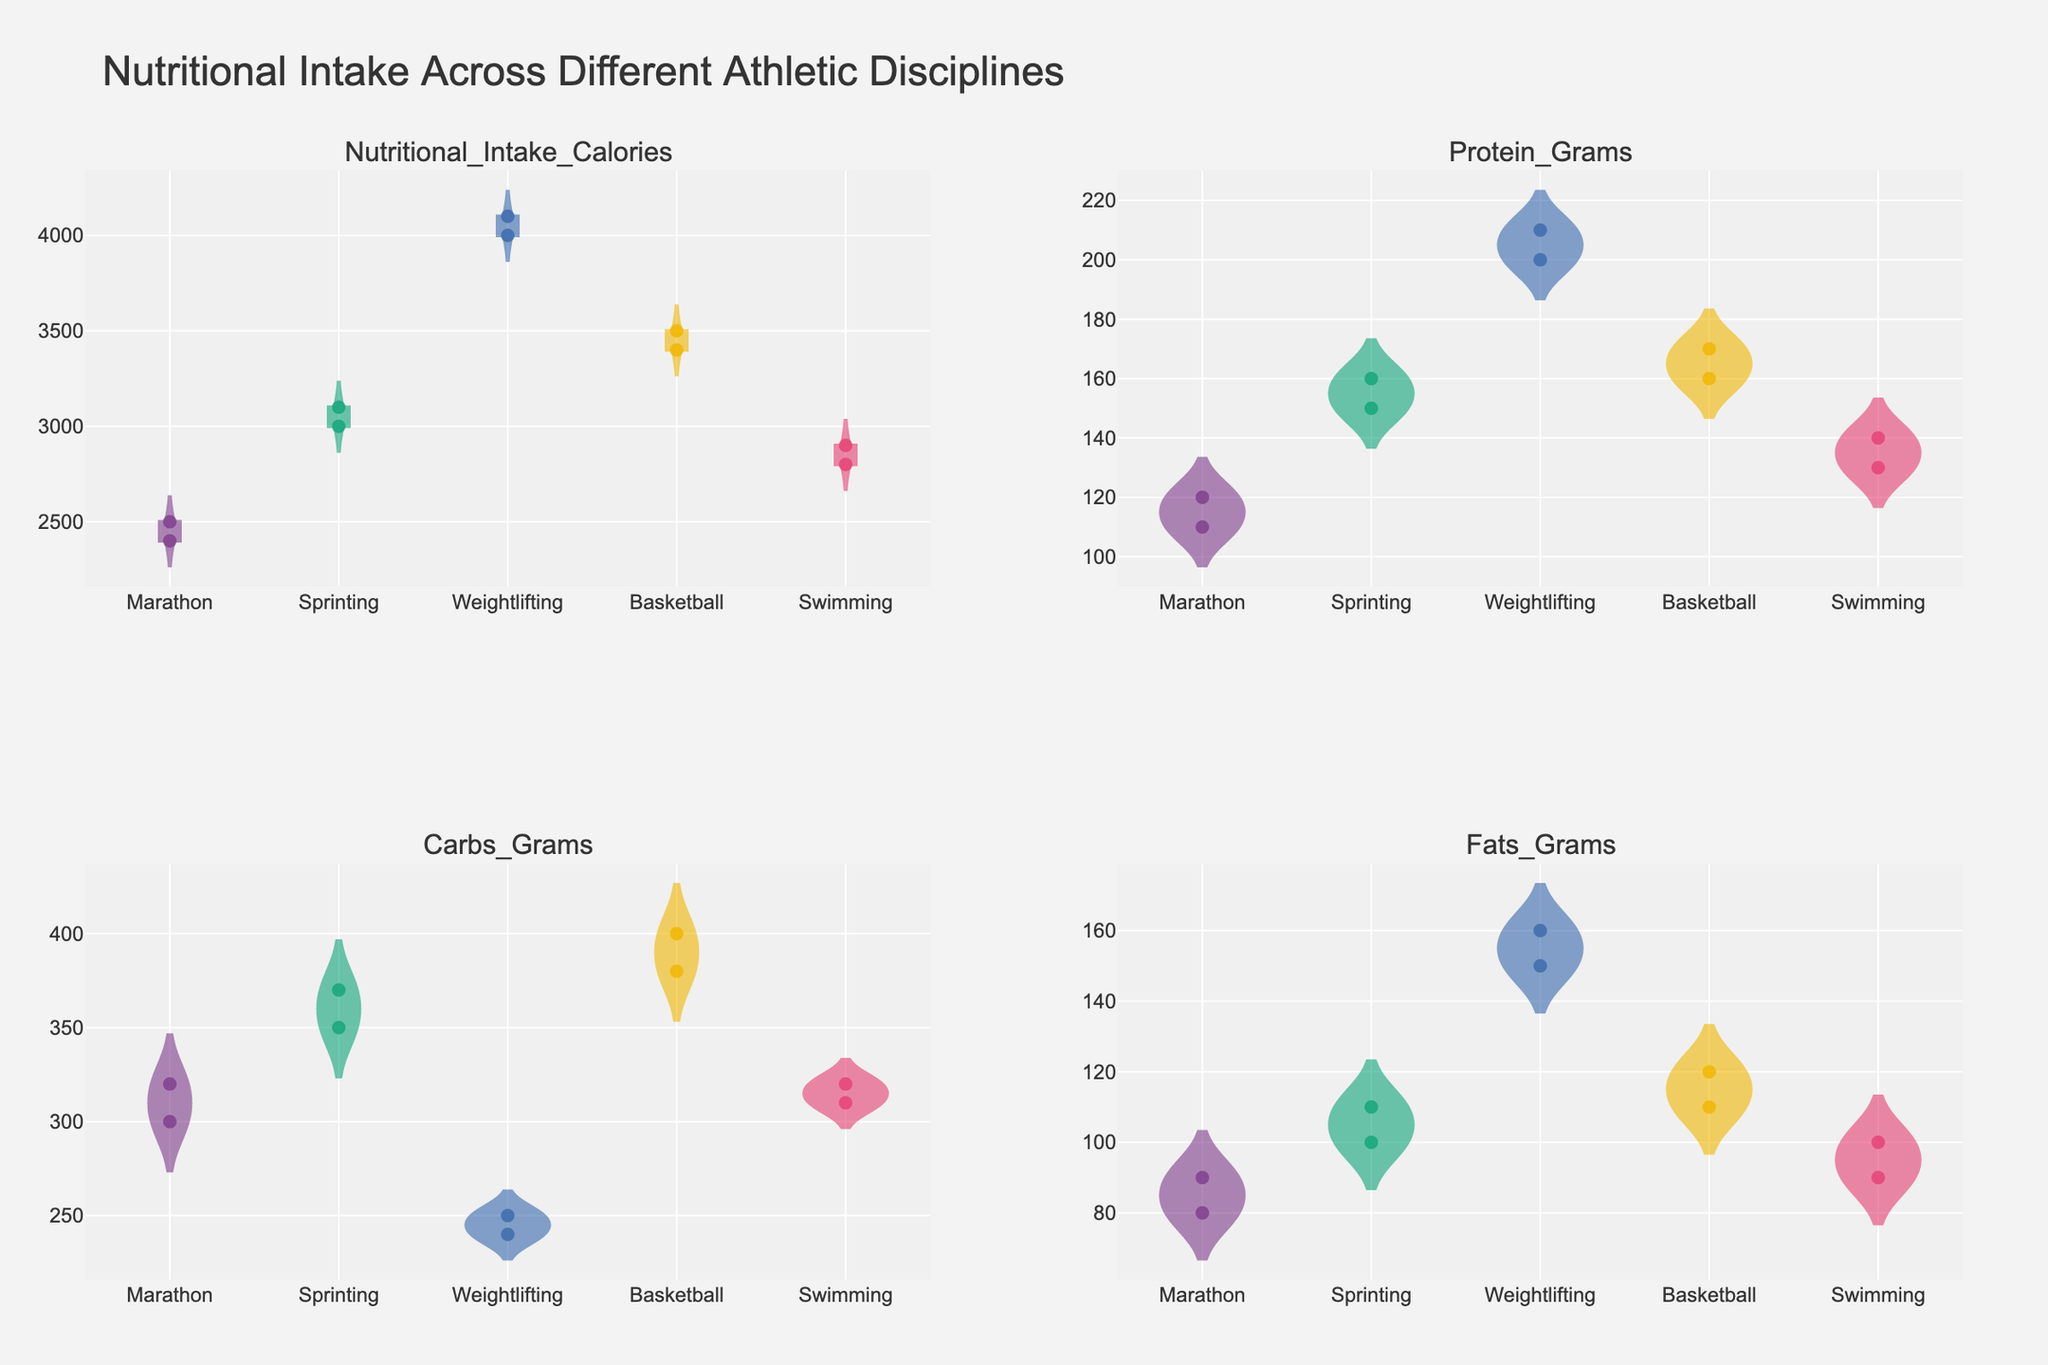What's the title of the figure? The title is located at the top center of the figure and reads "Nutritional Intake Across Different Athletic Disciplines".
Answer: Nutritional Intake Across Different Athletic Disciplines Which athletic discipline shows the highest average nutritional intake of calories? Look at the violin plots and identify the one with the highest average line for Nutritional Intake Calories. Weightlifting has the highest average.
Answer: Weightlifting How does the protein intake for weightlifters compare to that for marathon runners? Compare the positions of the protein intake violin plots. Weightlifters generally have higher protein intake values than marathon runners.
Answer: Weightlifters have higher protein intake Which discipline has the widest spread in carbs intake? The width of the violin plot for carbs grams indicates spread. Weightlifting has the widest spread.
Answer: Weightlifting Is there a noticeable difference in fat intake between weightlifters and sprinters? Compare the violin plots for fats grams. Weightlifters have higher fat intake than sprinters.
Answer: Weightlifters have higher fat intake What is the approximate average performance metric for swimmers? The average performance metric can be identified by the mean line in the swimmers' performance violin plot. It is around 1:54:45.
Answer: 1:54:45 Which discipline shows the least variation in calorie intake? The violin plot with the smallest width indicates the least variation. Swimming has the least variation in calorie intake.
Answer: Swimming Is there a clear correlation between carbs intake and performance for marathon runners? Review the violin plot for carbs grams and the performance metric for marathon runners. The relationship doesn't appear very clear.
Answer: No clear correlation How does the fat intake for basketball players compare to the average fat intake for all disciplines? Compare the average fat intake for basketball players to the overall distribution of fat intake values across other disciplines. Basketball players' fat intake appears average compared to others.
Answer: Average Do sprinters have a higher or lower average protein intake compared to weightlifters? Review the violin plots for protein grams. Sprinters have lower average protein intake compared to weightlifters.
Answer: Lower 